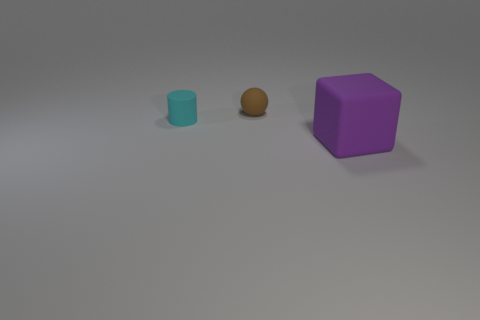What number of objects are things to the left of the big purple object or tiny brown rubber objects?
Offer a very short reply. 2. What material is the tiny thing that is on the left side of the brown rubber sphere behind the cylinder?
Give a very brief answer. Rubber. Are there any other large purple matte objects that have the same shape as the purple object?
Offer a terse response. No. Does the purple matte thing have the same size as the rubber object behind the small cyan object?
Give a very brief answer. No. How many things are small rubber things in front of the small brown rubber object or things that are to the left of the brown ball?
Provide a succinct answer. 1. Are there more matte objects that are to the left of the large purple cube than tiny cyan matte cylinders?
Your response must be concise. Yes. How many other rubber objects have the same size as the purple thing?
Your answer should be compact. 0. There is a rubber object that is behind the tiny cyan object; is it the same size as the matte thing in front of the tiny cyan thing?
Offer a very short reply. No. There is a matte object that is behind the tiny cyan rubber object; what is its size?
Keep it short and to the point. Small. What is the size of the object that is to the right of the tiny matte object right of the tiny cyan matte thing?
Give a very brief answer. Large. 